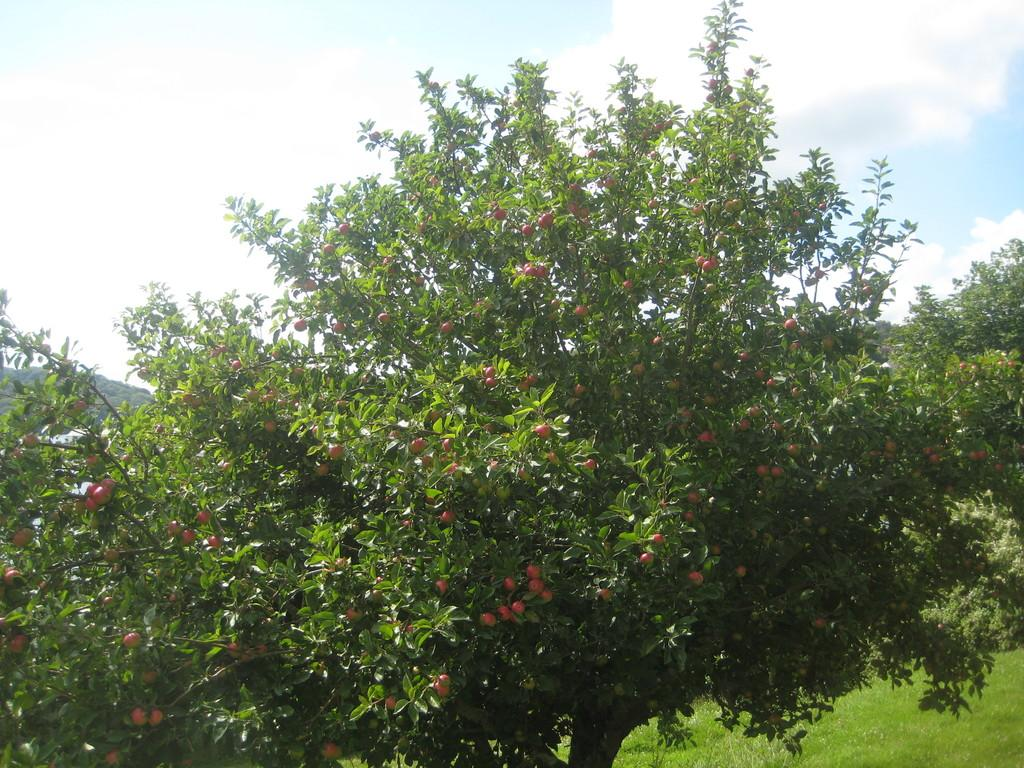What type of vegetation can be seen on the trees in the image? There are fruits on the trees in the image. What type of ground cover is visible at the bottom of the image? There is grass visible at the bottom of the image. What can be seen in the background of the image? The sky is visible in the background of the image. What type of theory is being discussed in the image? There is no discussion or mention of any theory in the image; it primarily features fruits on trees, grass, and the sky. 